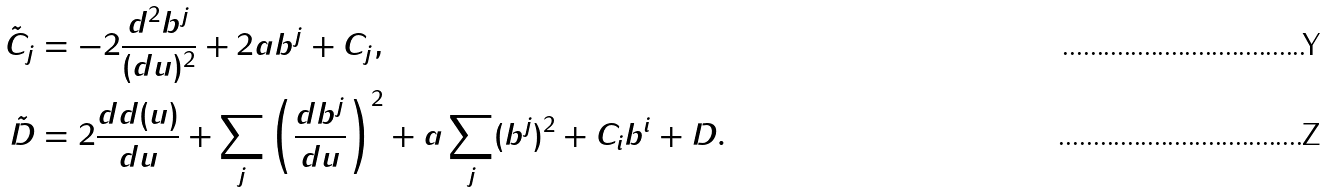Convert formula to latex. <formula><loc_0><loc_0><loc_500><loc_500>\tilde { C } _ { j } & = - 2 \frac { d ^ { 2 } b ^ { j } } { ( d u ) ^ { 2 } } + 2 a b ^ { j } + C _ { j } , \\ \tilde { D } & = 2 \frac { d d ( u ) } { d u } + \sum _ { j } \left ( \frac { d b ^ { j } } { d u } \right ) ^ { 2 } + a \sum _ { j } ( b ^ { j } ) ^ { 2 } + C _ { i } b ^ { i } + D .</formula> 